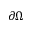Convert formula to latex. <formula><loc_0><loc_0><loc_500><loc_500>\partial \Omega</formula> 